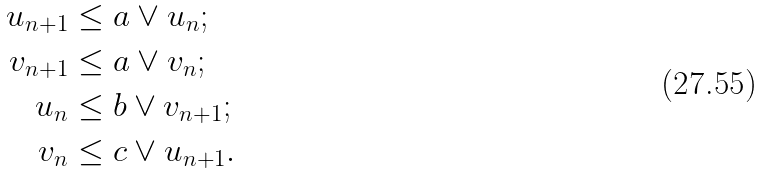<formula> <loc_0><loc_0><loc_500><loc_500>u _ { n + 1 } & \leq a \vee u _ { n } ; \\ v _ { n + 1 } & \leq a \vee v _ { n } ; \\ u _ { n } & \leq b \vee v _ { n + 1 } ; \\ v _ { n } & \leq c \vee u _ { n + 1 } .</formula> 